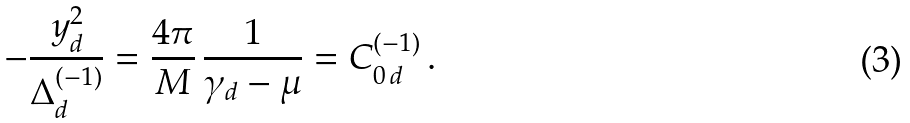<formula> <loc_0><loc_0><loc_500><loc_500>- \frac { y ^ { 2 } _ { d } } { \Delta ^ { ( - 1 ) } _ { d } } = \frac { 4 \pi } { M } \, \frac { 1 } { \gamma _ { d } - \mu } = C _ { 0 \, d } ^ { ( - 1 ) } \, .</formula> 